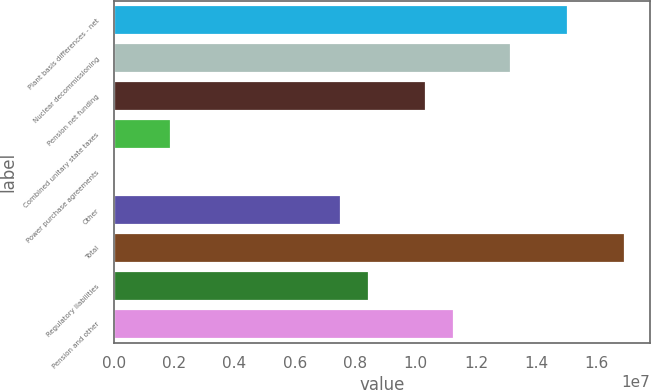Convert chart to OTSL. <chart><loc_0><loc_0><loc_500><loc_500><bar_chart><fcel>Plant basis differences - net<fcel>Nuclear decommissioning<fcel>Pension net funding<fcel>Combined unitary state taxes<fcel>Power purchase agreements<fcel>Other<fcel>Total<fcel>Regulatory liabilities<fcel>Pension and other<nl><fcel>1.50444e+07<fcel>1.3164e+07<fcel>1.03433e+07<fcel>1.88142e+06<fcel>993<fcel>7.5227e+06<fcel>1.69248e+07<fcel>8.46291e+06<fcel>1.12836e+07<nl></chart> 